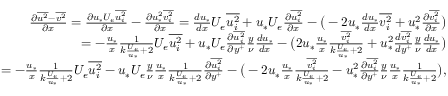<formula> <loc_0><loc_0><loc_500><loc_500>\begin{array} { r } { \frac { \partial \overline { { u ^ { 2 } } } - \overline { { v ^ { 2 } } } } { \partial x } = \frac { \partial u _ { * } U _ { e } \overline { { u _ { i } ^ { 2 } } } } { \partial x } - \frac { \partial u _ { * } ^ { 2 } \overline { { v _ { i } ^ { 2 } } } } { \partial x } = \frac { d u _ { * } } { d x } U _ { e } \overline { { u _ { i } ^ { 2 } } } + u _ { * } U _ { e } \frac { \partial \overline { { u _ { i } ^ { 2 } } } } { \partial x } - \left ( - 2 u _ { * } \frac { d u _ { * } } { d x } \overline { { v _ { i } ^ { 2 } } } + u _ { * } ^ { 2 } \frac { \partial \overline { { v _ { i } ^ { 2 } } } } { \partial x } \right ) } \\ { = - \frac { u _ { * } } { x } \frac { 1 } { k \frac { U _ { e } } { u _ { * } } + 2 } U _ { e } \overline { { u _ { i } ^ { 2 } } } + u _ { * } U _ { e } \frac { \partial \overline { { u _ { i } ^ { 2 } } } } { \partial y ^ { + } } \frac { y } { \nu } \frac { d u _ { * } } { d x } - \left ( 2 u _ { * } \frac { u _ { * } } { x } \frac { \overline { { v _ { i } ^ { 2 } } } } { k \frac { U _ { e } } { u _ { * } } + 2 } + u _ { * } ^ { 2 } \frac { d \overline { { v _ { i } ^ { 2 } } } } { d y ^ { + } } \frac { y } { \nu } \frac { d u _ { * } } { d x } \right ) } \\ { = - \frac { u _ { * } } { x } \frac { 1 } { k \frac { U _ { e } } { u _ { * } } + 2 } U _ { e } \overline { { u _ { i } ^ { 2 } } } - u _ { * } U _ { e } \frac { y } { \nu } \frac { u _ { * } } { x } \frac { 1 } { k \frac { U _ { e } } { u _ { * } } + 2 } \frac { \partial \overline { { u _ { i } ^ { 2 } } } } { \partial y ^ { + } } - \left ( - 2 u _ { * } \frac { u _ { * } } { x } \frac { \overline { { v _ { i } ^ { 2 } } } } { k \frac { U _ { e } } { u _ { * } } + 2 } - u _ { * } ^ { 2 } \frac { \partial \overline { { u _ { i } ^ { 2 } } } } { \partial y ^ { + } } \frac { y } { \nu } \frac { u _ { * } } { x } \frac { 1 } { k \frac { U _ { e } } { u _ { * } } + 2 } \right ) , } \end{array}</formula> 